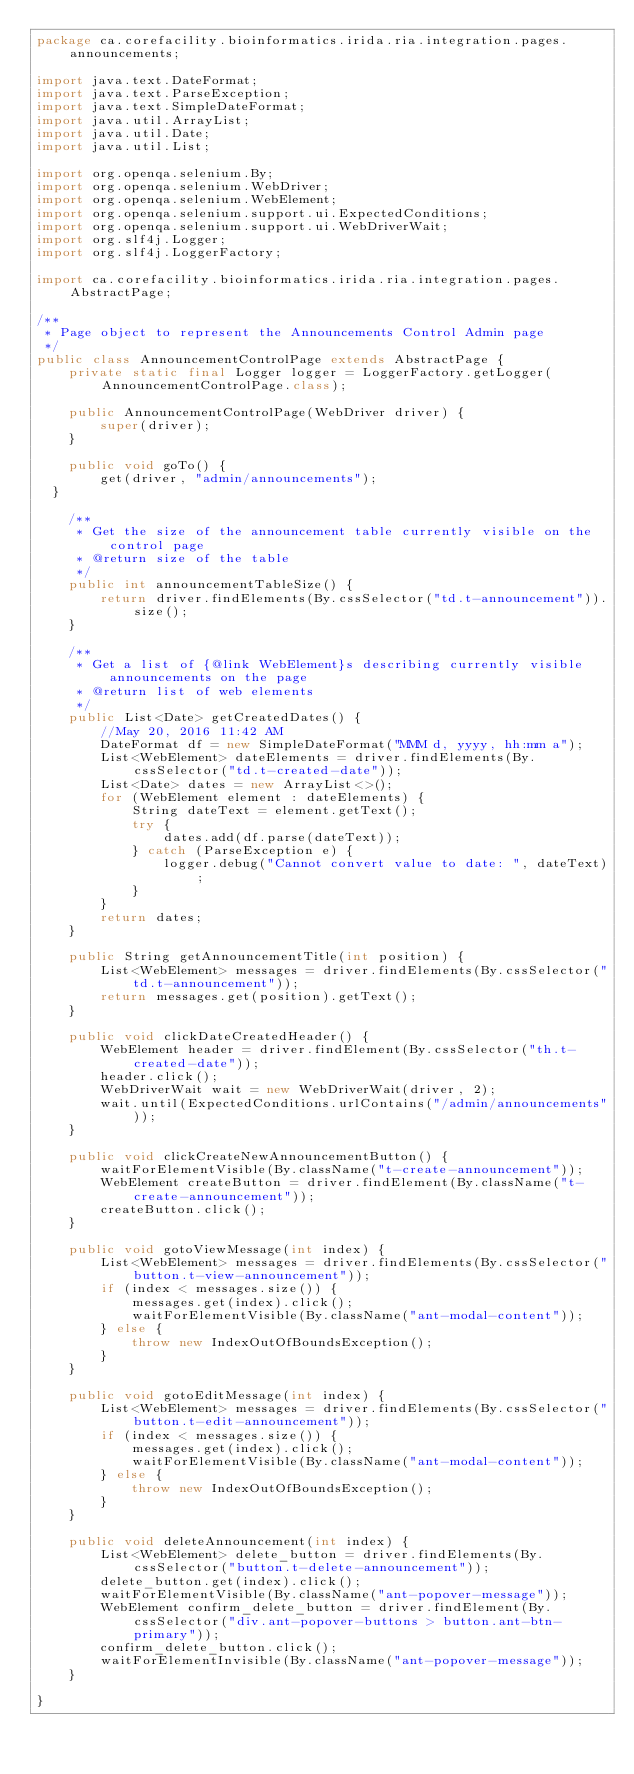Convert code to text. <code><loc_0><loc_0><loc_500><loc_500><_Java_>package ca.corefacility.bioinformatics.irida.ria.integration.pages.announcements;

import java.text.DateFormat;
import java.text.ParseException;
import java.text.SimpleDateFormat;
import java.util.ArrayList;
import java.util.Date;
import java.util.List;

import org.openqa.selenium.By;
import org.openqa.selenium.WebDriver;
import org.openqa.selenium.WebElement;
import org.openqa.selenium.support.ui.ExpectedConditions;
import org.openqa.selenium.support.ui.WebDriverWait;
import org.slf4j.Logger;
import org.slf4j.LoggerFactory;

import ca.corefacility.bioinformatics.irida.ria.integration.pages.AbstractPage;

/**
 * Page object to represent the Announcements Control Admin page
 */
public class AnnouncementControlPage extends AbstractPage {
    private static final Logger logger = LoggerFactory.getLogger(AnnouncementControlPage.class);

    public AnnouncementControlPage(WebDriver driver) {
        super(driver);
    }

    public void goTo() {
        get(driver, "admin/announcements");
	}

    /**
     * Get the size of the announcement table currently visible on the control page
     * @return size of the table
     */
    public int announcementTableSize() {
        return driver.findElements(By.cssSelector("td.t-announcement")).size();
    }

    /**
     * Get a list of {@link WebElement}s describing currently visible announcements on the page
     * @return list of web elements
     */
    public List<Date> getCreatedDates() {
        //May 20, 2016 11:42 AM
        DateFormat df = new SimpleDateFormat("MMM d, yyyy, hh:mm a");
        List<WebElement> dateElements = driver.findElements(By.cssSelector("td.t-created-date"));
        List<Date> dates = new ArrayList<>();
        for (WebElement element : dateElements) {
            String dateText = element.getText();
            try {
                dates.add(df.parse(dateText));
            } catch (ParseException e) {
                logger.debug("Cannot convert value to date: ", dateText);
            }
        }
        return dates;
    }

    public String getAnnouncementTitle(int position) {
        List<WebElement> messages = driver.findElements(By.cssSelector("td.t-announcement"));
        return messages.get(position).getText();
    }

    public void clickDateCreatedHeader() {
        WebElement header = driver.findElement(By.cssSelector("th.t-created-date"));
        header.click();
        WebDriverWait wait = new WebDriverWait(driver, 2);
        wait.until(ExpectedConditions.urlContains("/admin/announcements"));
    }

    public void clickCreateNewAnnouncementButton() {
        waitForElementVisible(By.className("t-create-announcement"));
        WebElement createButton = driver.findElement(By.className("t-create-announcement"));
        createButton.click();
    }

    public void gotoViewMessage(int index) {
        List<WebElement> messages = driver.findElements(By.cssSelector("button.t-view-announcement"));
        if (index < messages.size()) {
            messages.get(index).click();
            waitForElementVisible(By.className("ant-modal-content"));
        } else {
            throw new IndexOutOfBoundsException();
        }
    }

    public void gotoEditMessage(int index) {
        List<WebElement> messages = driver.findElements(By.cssSelector("button.t-edit-announcement"));
        if (index < messages.size()) {
            messages.get(index).click();
            waitForElementVisible(By.className("ant-modal-content"));
        } else {
            throw new IndexOutOfBoundsException();
        }
    }

    public void deleteAnnouncement(int index) {
        List<WebElement> delete_button = driver.findElements(By.cssSelector("button.t-delete-announcement"));
        delete_button.get(index).click();
        waitForElementVisible(By.className("ant-popover-message"));
        WebElement confirm_delete_button = driver.findElement(By.cssSelector("div.ant-popover-buttons > button.ant-btn-primary"));
        confirm_delete_button.click();
        waitForElementInvisible(By.className("ant-popover-message"));
    }

}
</code> 